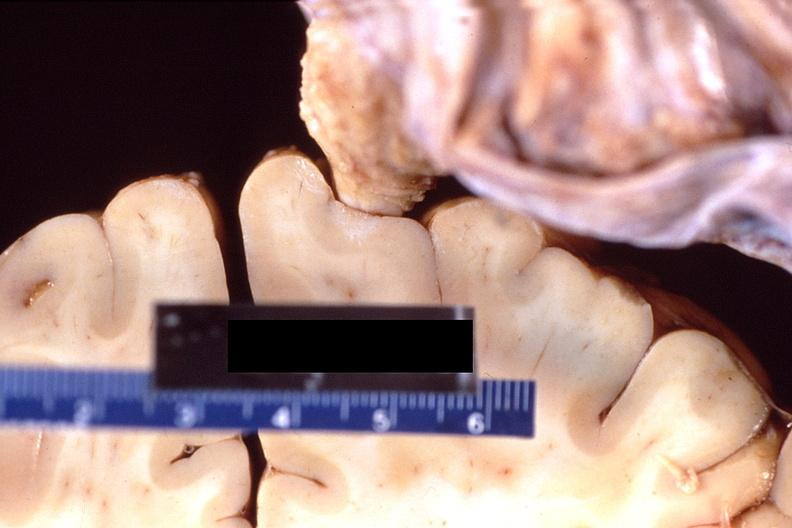s natural color present?
Answer the question using a single word or phrase. No 